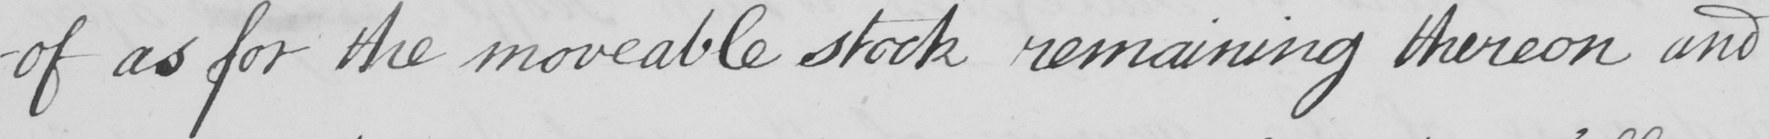What does this handwritten line say? as for the moveable stock remaining thereon and 